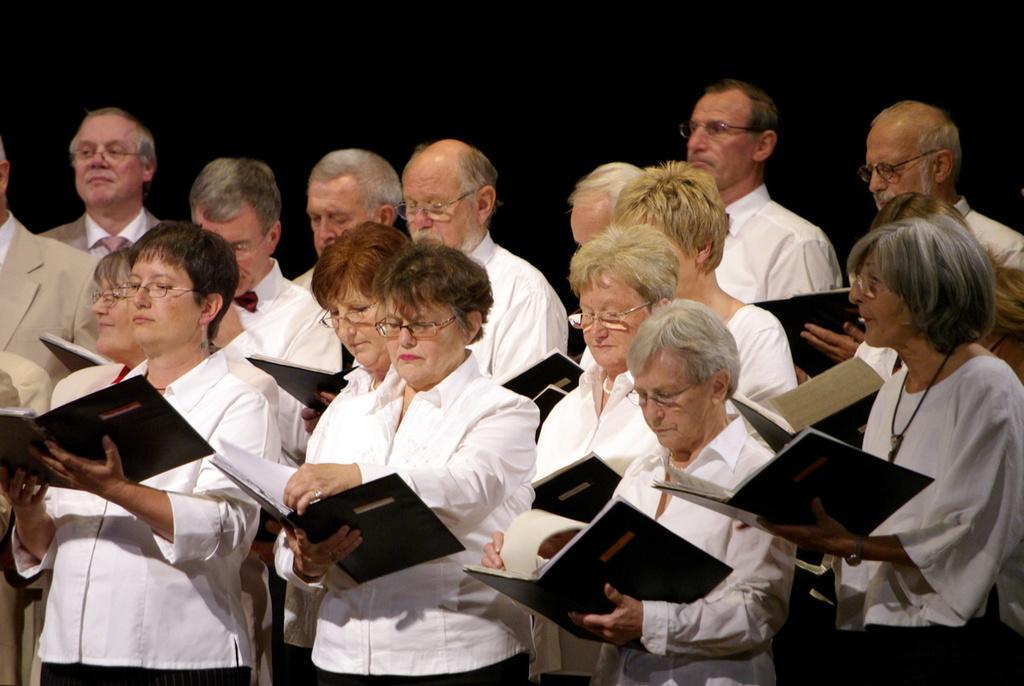Describe this image in one or two sentences. In the image we can see there are people standing and they are holding books in their hand. 